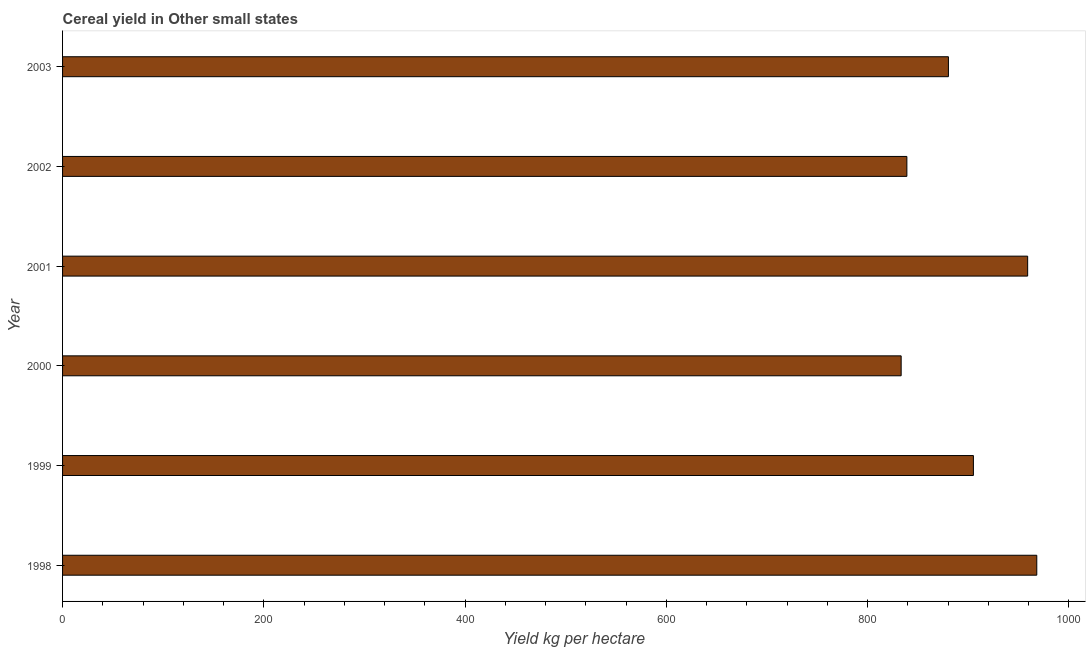What is the title of the graph?
Ensure brevity in your answer.  Cereal yield in Other small states. What is the label or title of the X-axis?
Give a very brief answer. Yield kg per hectare. What is the label or title of the Y-axis?
Your response must be concise. Year. What is the cereal yield in 2002?
Offer a very short reply. 838.96. Across all years, what is the maximum cereal yield?
Offer a very short reply. 968.04. Across all years, what is the minimum cereal yield?
Your answer should be very brief. 833.28. In which year was the cereal yield maximum?
Offer a terse response. 1998. What is the sum of the cereal yield?
Your response must be concise. 5384.56. What is the difference between the cereal yield in 1999 and 2000?
Make the answer very short. 71.79. What is the average cereal yield per year?
Offer a terse response. 897.43. What is the median cereal yield?
Your answer should be very brief. 892.66. In how many years, is the cereal yield greater than 40 kg per hectare?
Provide a succinct answer. 6. Is the difference between the cereal yield in 2000 and 2002 greater than the difference between any two years?
Your response must be concise. No. What is the difference between the highest and the second highest cereal yield?
Offer a very short reply. 9.06. What is the difference between the highest and the lowest cereal yield?
Keep it short and to the point. 134.76. How many bars are there?
Provide a succinct answer. 6. How many years are there in the graph?
Offer a very short reply. 6. Are the values on the major ticks of X-axis written in scientific E-notation?
Ensure brevity in your answer.  No. What is the Yield kg per hectare of 1998?
Your answer should be very brief. 968.04. What is the Yield kg per hectare in 1999?
Keep it short and to the point. 905.07. What is the Yield kg per hectare in 2000?
Provide a succinct answer. 833.28. What is the Yield kg per hectare in 2001?
Your answer should be compact. 958.97. What is the Yield kg per hectare in 2002?
Keep it short and to the point. 838.96. What is the Yield kg per hectare of 2003?
Offer a very short reply. 880.24. What is the difference between the Yield kg per hectare in 1998 and 1999?
Offer a terse response. 62.97. What is the difference between the Yield kg per hectare in 1998 and 2000?
Your answer should be very brief. 134.76. What is the difference between the Yield kg per hectare in 1998 and 2001?
Offer a very short reply. 9.06. What is the difference between the Yield kg per hectare in 1998 and 2002?
Give a very brief answer. 129.08. What is the difference between the Yield kg per hectare in 1998 and 2003?
Provide a short and direct response. 87.8. What is the difference between the Yield kg per hectare in 1999 and 2000?
Keep it short and to the point. 71.79. What is the difference between the Yield kg per hectare in 1999 and 2001?
Your answer should be compact. -53.9. What is the difference between the Yield kg per hectare in 1999 and 2002?
Keep it short and to the point. 66.11. What is the difference between the Yield kg per hectare in 1999 and 2003?
Make the answer very short. 24.83. What is the difference between the Yield kg per hectare in 2000 and 2001?
Your answer should be compact. -125.69. What is the difference between the Yield kg per hectare in 2000 and 2002?
Your answer should be very brief. -5.68. What is the difference between the Yield kg per hectare in 2000 and 2003?
Provide a succinct answer. -46.96. What is the difference between the Yield kg per hectare in 2001 and 2002?
Your response must be concise. 120.01. What is the difference between the Yield kg per hectare in 2001 and 2003?
Your answer should be compact. 78.73. What is the difference between the Yield kg per hectare in 2002 and 2003?
Give a very brief answer. -41.28. What is the ratio of the Yield kg per hectare in 1998 to that in 1999?
Provide a succinct answer. 1.07. What is the ratio of the Yield kg per hectare in 1998 to that in 2000?
Provide a succinct answer. 1.16. What is the ratio of the Yield kg per hectare in 1998 to that in 2002?
Your response must be concise. 1.15. What is the ratio of the Yield kg per hectare in 1999 to that in 2000?
Give a very brief answer. 1.09. What is the ratio of the Yield kg per hectare in 1999 to that in 2001?
Your response must be concise. 0.94. What is the ratio of the Yield kg per hectare in 1999 to that in 2002?
Provide a succinct answer. 1.08. What is the ratio of the Yield kg per hectare in 1999 to that in 2003?
Give a very brief answer. 1.03. What is the ratio of the Yield kg per hectare in 2000 to that in 2001?
Offer a very short reply. 0.87. What is the ratio of the Yield kg per hectare in 2000 to that in 2003?
Provide a short and direct response. 0.95. What is the ratio of the Yield kg per hectare in 2001 to that in 2002?
Offer a very short reply. 1.14. What is the ratio of the Yield kg per hectare in 2001 to that in 2003?
Your answer should be very brief. 1.09. What is the ratio of the Yield kg per hectare in 2002 to that in 2003?
Give a very brief answer. 0.95. 